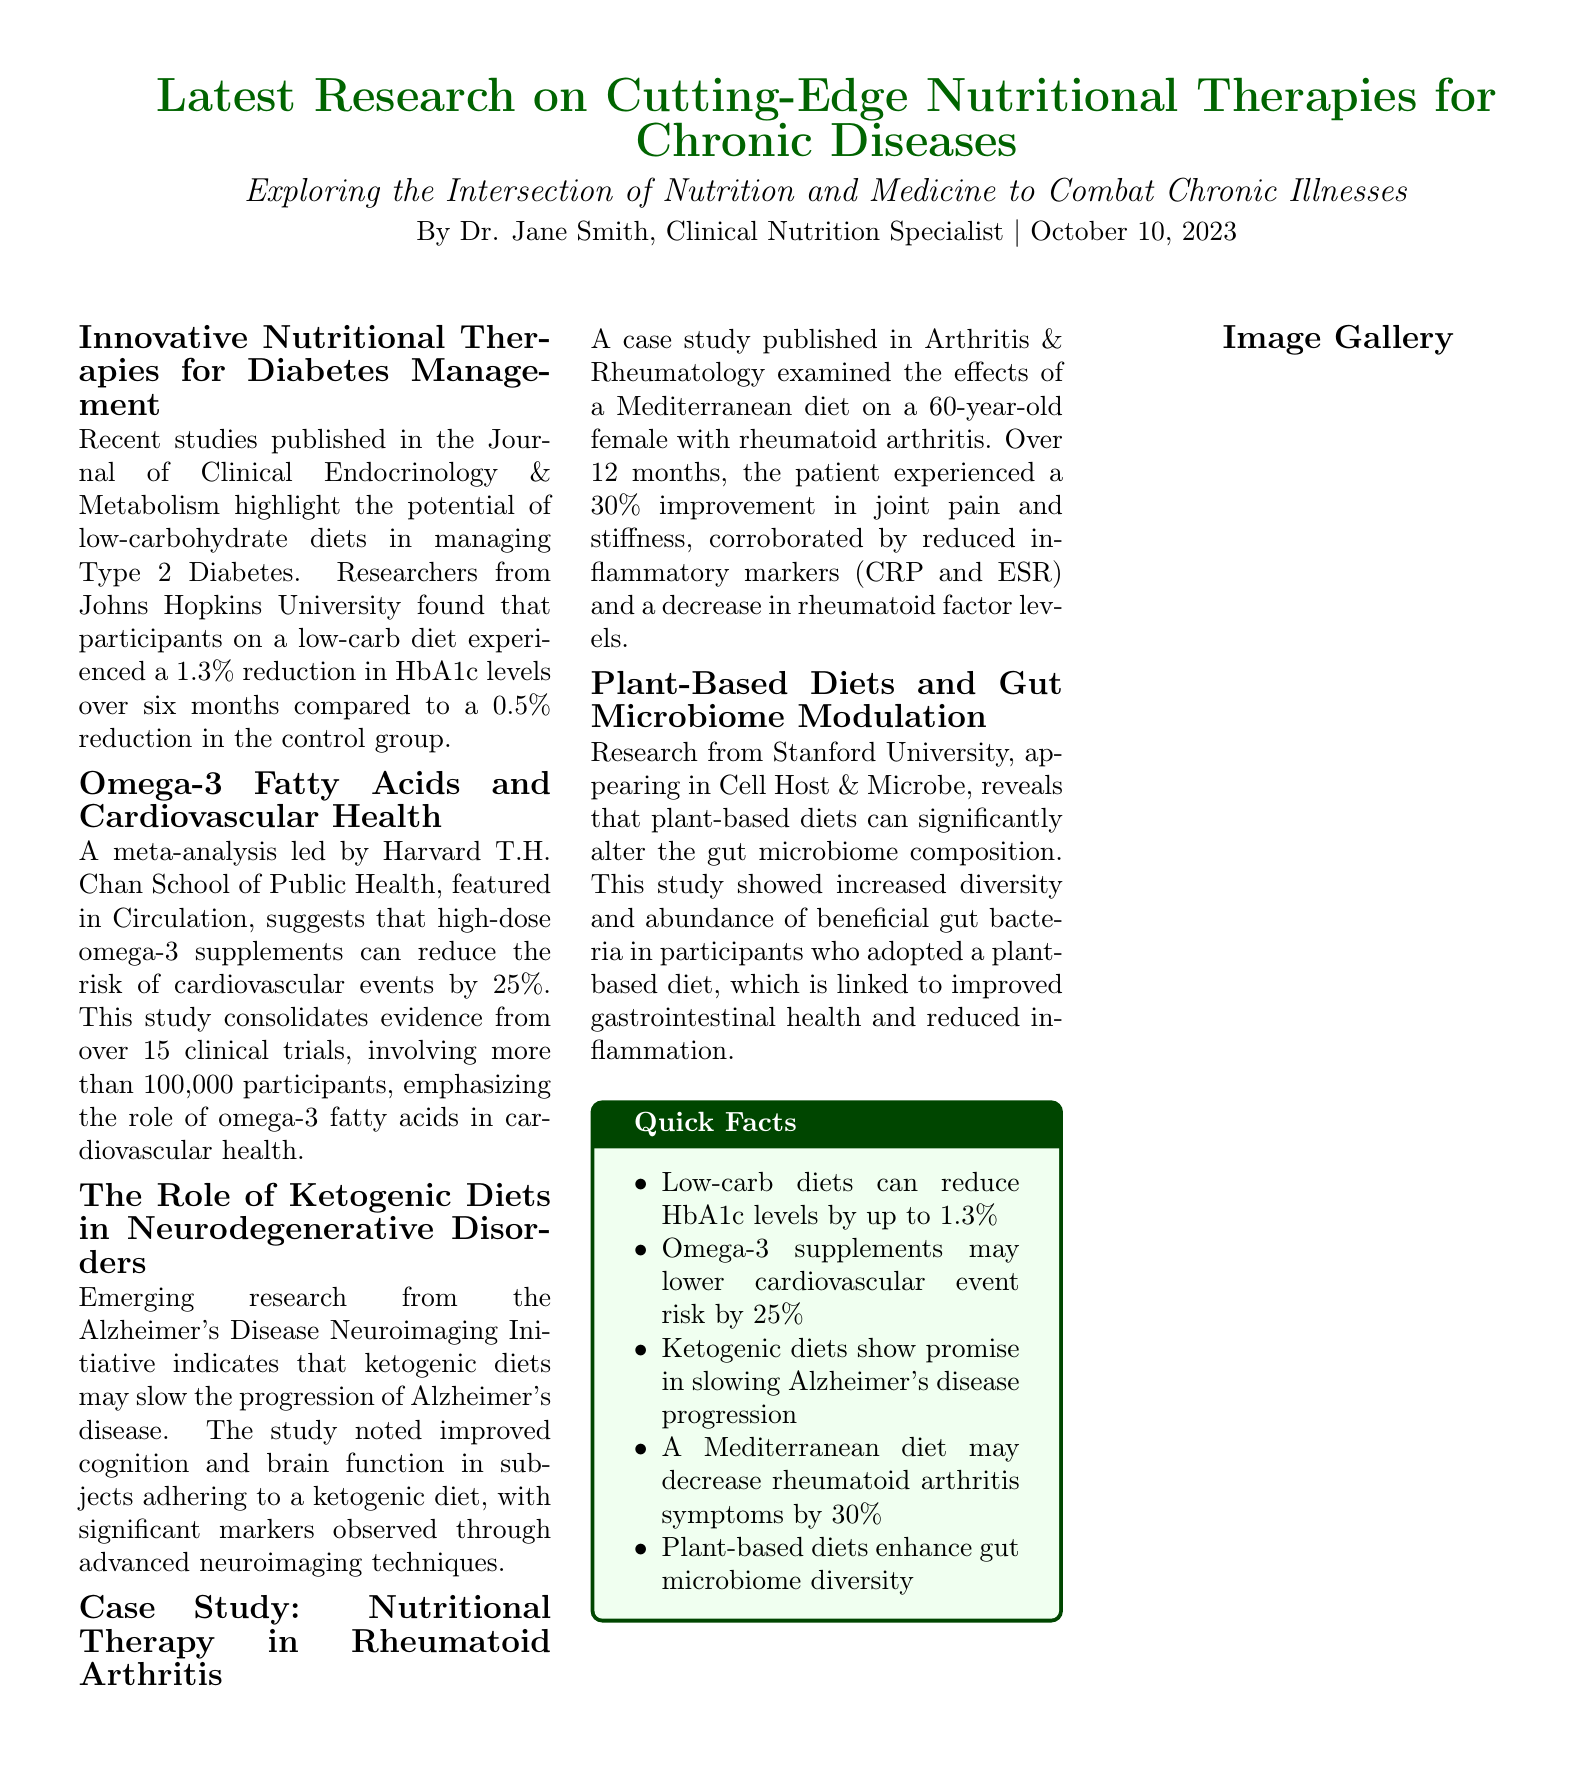What is the primary focus of the article? The article focuses on exploring the intersection of nutrition and medicine to combat chronic illnesses.
Answer: Intersection of nutrition and medicine Which diet resulted in a 1.3% reduction in HbA1c levels? The article reports that participants on a low-carb diet experienced a 1.3% reduction in HbA1c levels.
Answer: Low-carb diet What percentage improvement in joint pain was observed in the case study? The case study indicated that the patient experienced a 30% improvement in joint pain and stiffness.
Answer: 30% In which journal is the research about omega-3 fatty acids published? The meta-analysis about omega-3 fatty acids is featured in the journal Circulation.
Answer: Circulation How many participants were involved in the omega-3 fatty acids study? The study consolidated evidence from over 15 clinical trials, involving more than 100,000 participants.
Answer: More than 100,000 What nutritional approach may help slow the progression of Alzheimer's disease? The article mentions that ketogenic diets may slow the progression of Alzheimer's disease.
Answer: Ketogenic diets Who authored the article? The article is authored by Dr. Jane Smith, Clinical Nutrition Specialist.
Answer: Dr. Jane Smith What specific dietary change was shown to enhance gut microbiome diversity? The research indicates that plant-based diets enhance gut microbiome diversity.
Answer: Plant-based diets What type of article layout is used in this document? This document uses a newspaper layout format to present its information.
Answer: Newspaper layout 